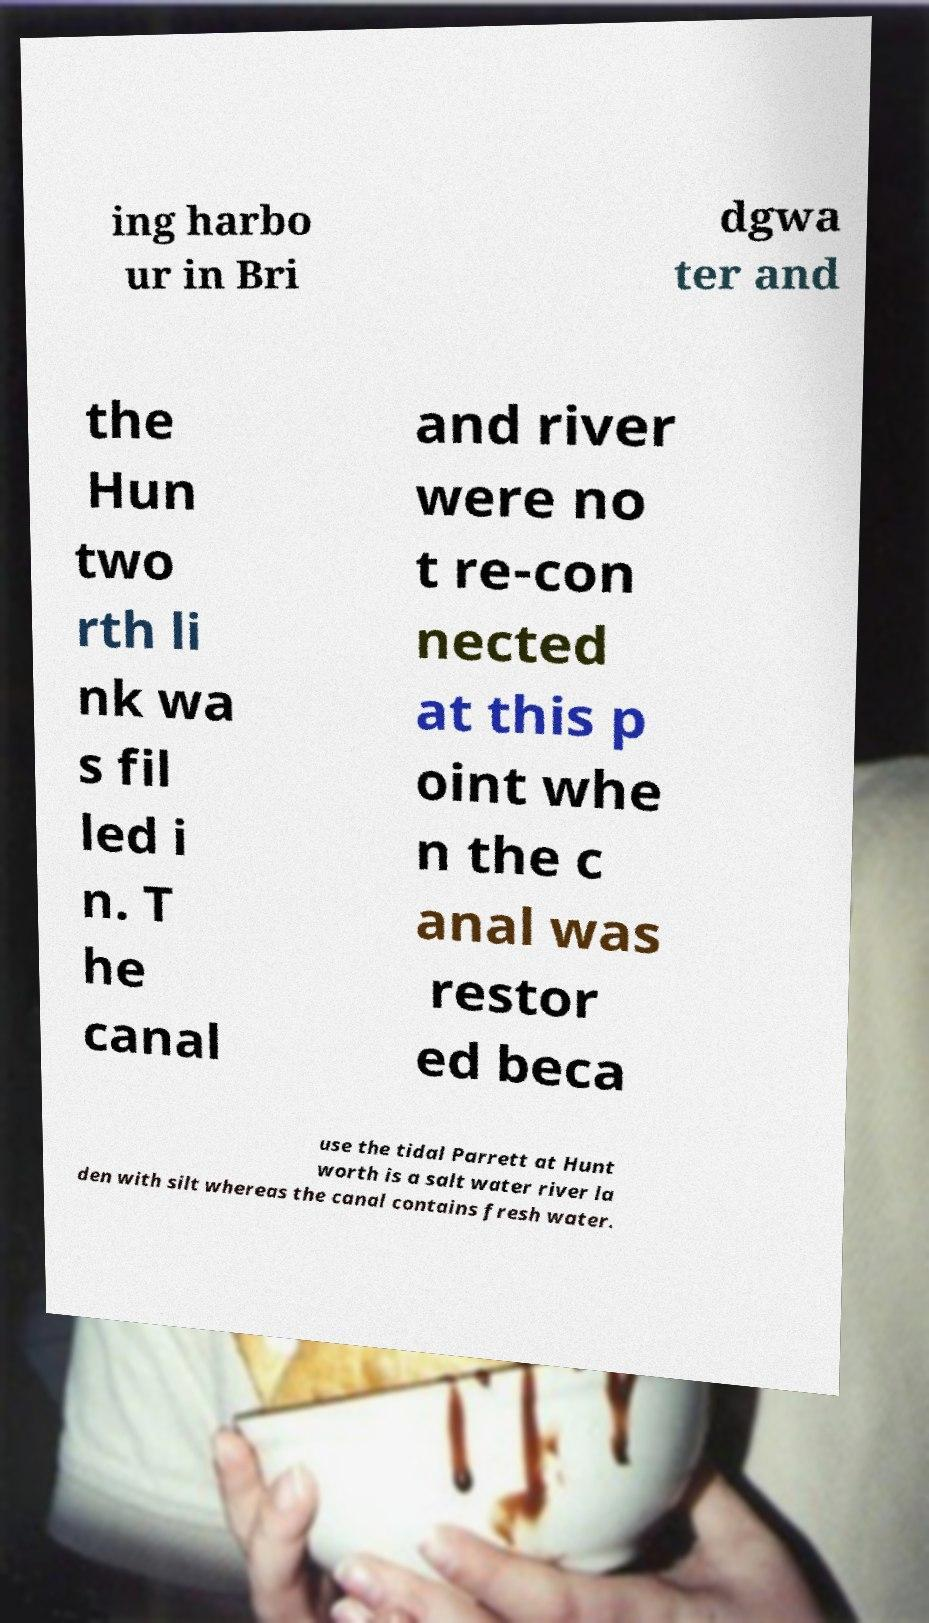Please identify and transcribe the text found in this image. ing harbo ur in Bri dgwa ter and the Hun two rth li nk wa s fil led i n. T he canal and river were no t re-con nected at this p oint whe n the c anal was restor ed beca use the tidal Parrett at Hunt worth is a salt water river la den with silt whereas the canal contains fresh water. 